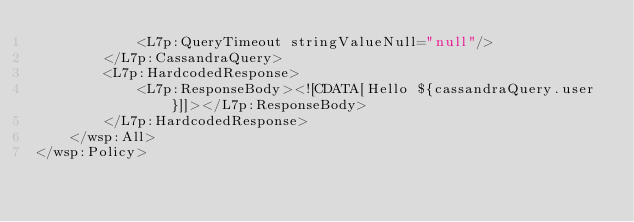Convert code to text. <code><loc_0><loc_0><loc_500><loc_500><_XML_>            <L7p:QueryTimeout stringValueNull="null"/>
        </L7p:CassandraQuery>
        <L7p:HardcodedResponse>
            <L7p:ResponseBody><![CDATA[Hello ${cassandraQuery.user}]]></L7p:ResponseBody>
        </L7p:HardcodedResponse>
    </wsp:All>
</wsp:Policy>
</code> 